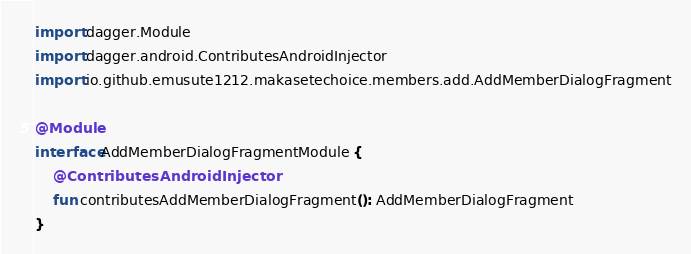Convert code to text. <code><loc_0><loc_0><loc_500><loc_500><_Kotlin_>import dagger.Module
import dagger.android.ContributesAndroidInjector
import io.github.emusute1212.makasetechoice.members.add.AddMemberDialogFragment

@Module
interface AddMemberDialogFragmentModule {
    @ContributesAndroidInjector
    fun contributesAddMemberDialogFragment(): AddMemberDialogFragment
}</code> 